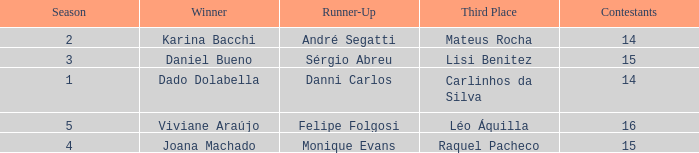How many contestants were there when the runner-up was Monique Evans? 15.0. Could you parse the entire table as a dict? {'header': ['Season', 'Winner', 'Runner-Up', 'Third Place', 'Contestants'], 'rows': [['2', 'Karina Bacchi', 'André Segatti', 'Mateus Rocha', '14'], ['3', 'Daniel Bueno', 'Sérgio Abreu', 'Lisi Benitez', '15'], ['1', 'Dado Dolabella', 'Danni Carlos', 'Carlinhos da Silva', '14'], ['5', 'Viviane Araújo', 'Felipe Folgosi', 'Léo Áquilla', '16'], ['4', 'Joana Machado', 'Monique Evans', 'Raquel Pacheco', '15']]} 